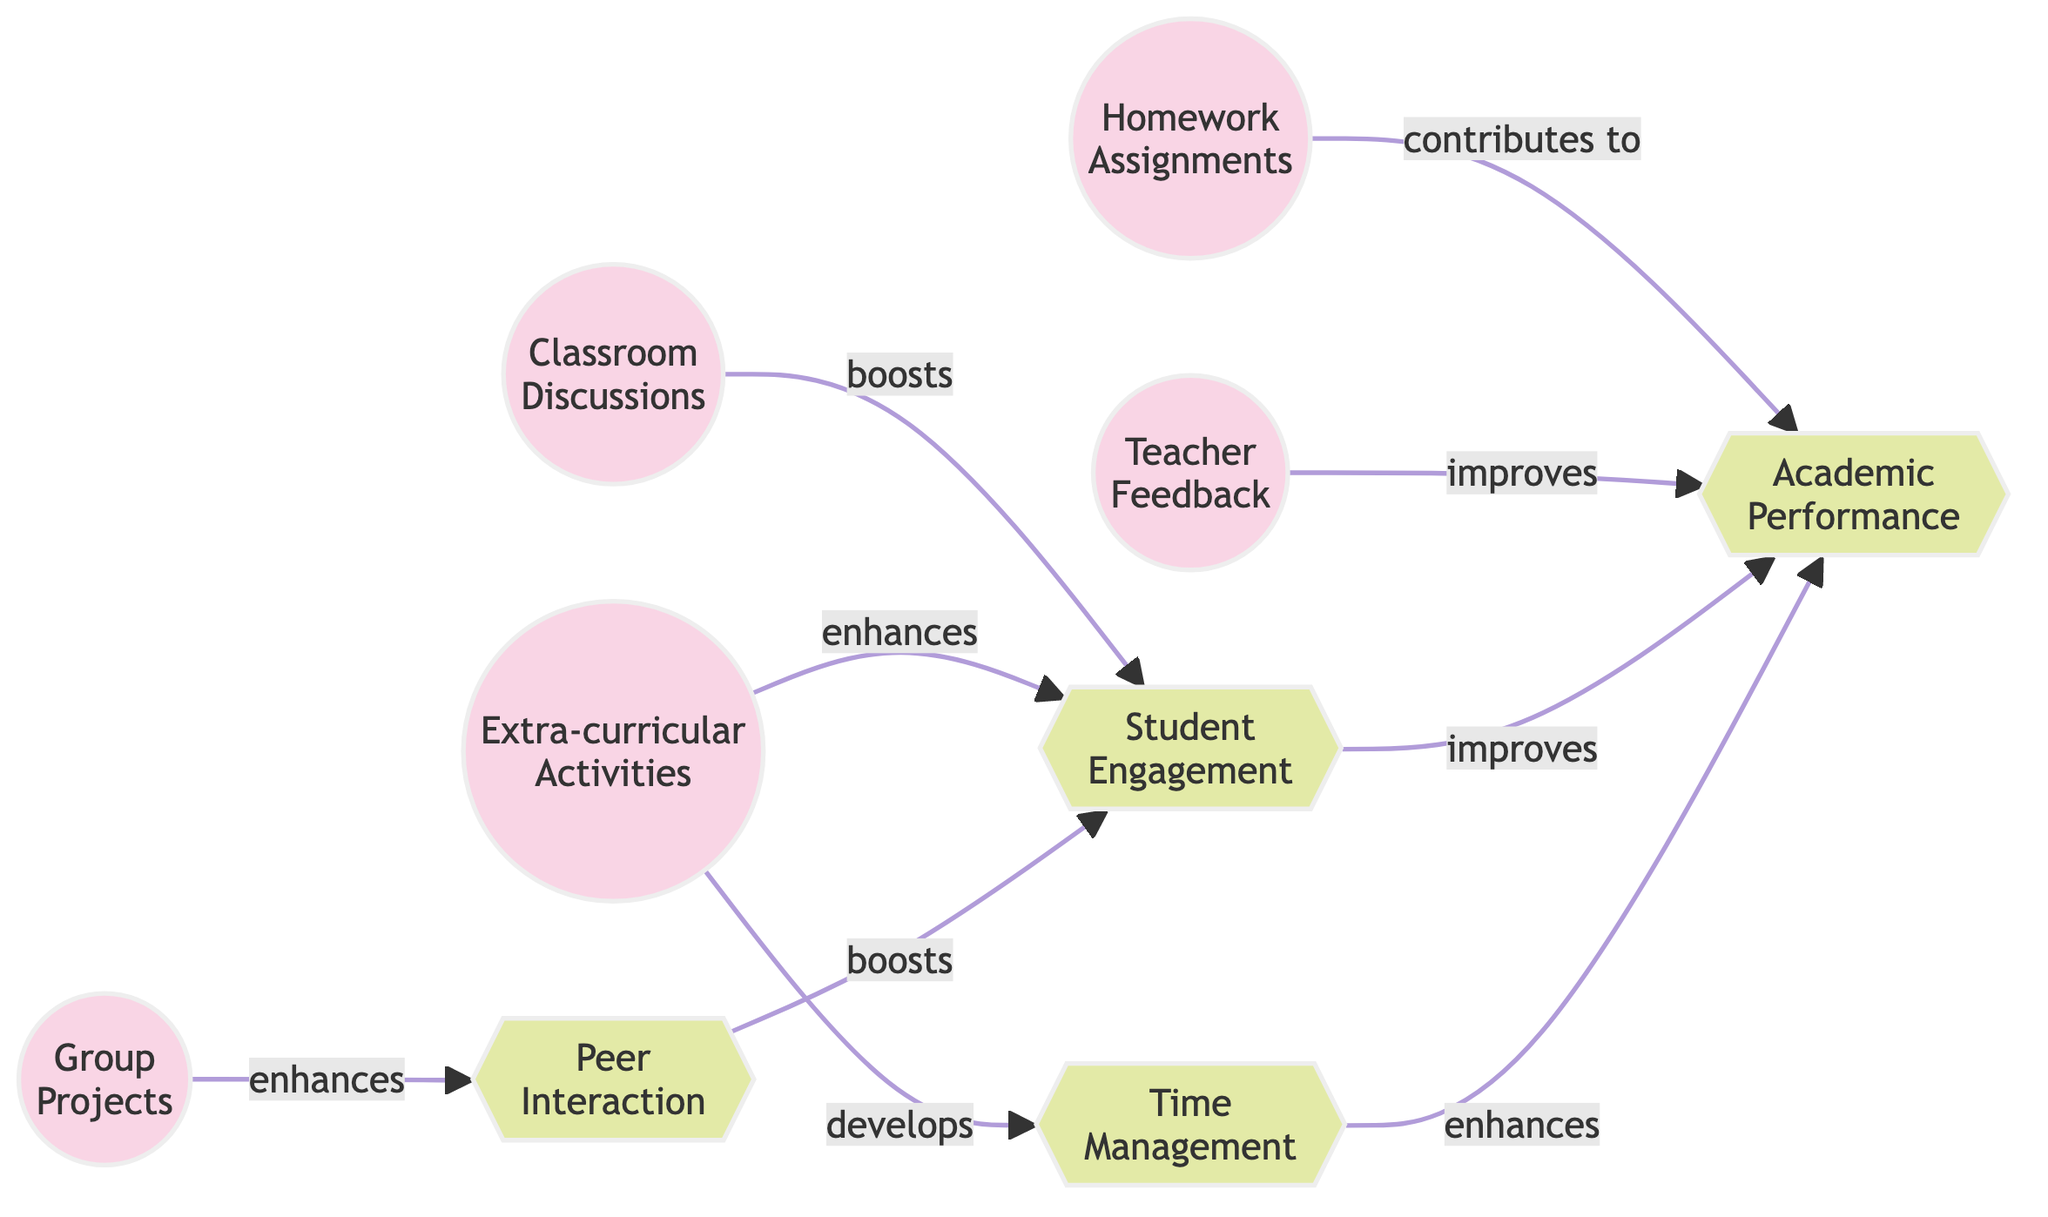What is the total number of nodes in the diagram? The diagram lists the following nodes: Homework Assignments, Group Projects, Classroom Discussions, Teacher Feedback, Extra-curricular Activities, Student Engagement, Academic Performance, Peer Interaction, and Time Management. Counting these gives a total of 9 nodes.
Answer: 9 Which activity boosts student engagement? According to the diagram, Classroom Discussions boosts Student Engagement, as indicated by the directed edge labeled "boosts" from Classroom Discussions to Student Engagement.
Answer: Classroom Discussions How many edges lead into academic performance? Academic Performance has three edges leading into it from Homework Assignments, Teacher Feedback, and Student Engagement. Counting these gives a total of 3 edges pointing towards Academic Performance.
Answer: 3 Do extra-curricular activities improve peer interaction? According to the diagram, Extra-curricular Activities does not directly influence Peer Interaction, as there is no edge connecting Extra-curricular Activities to Peer Interaction. Instead, it enhances Student Engagement and develops Time Management.
Answer: No Which influence is directly enhanced by group projects? The edge originating from Group Projects indicates that it enhances Peer Interaction, showing a direct relationship where group projects improve peer interaction among students.
Answer: Peer Interaction Is there a path from time management to academic performance? Yes, there is a direct edge from Time Management to Academic Performance labeled "enhances," indicating that it influences academic performance positively without the need for intermediate nodes.
Answer: Yes Which activity is reported to improve academic performance? Teacher Feedback is explicitly stated to improve Academic Performance, as shown by the edge connecting Teacher Feedback to Academic Performance with the label "improves."
Answer: Teacher Feedback What effect does student engagement have on academic performance? The directed edge from Student Engagement to Academic Performance indicates that Student Engagement improves Academic Performance, highlighting the positive effect of engaging students in learning.
Answer: Improves How many influences are shown in the diagram? The diagram lists the influences, which are Student Engagement, Academic Performance, Peer Interaction, and Time Management. Counting these influences results in a total of 4 influences.
Answer: 4 